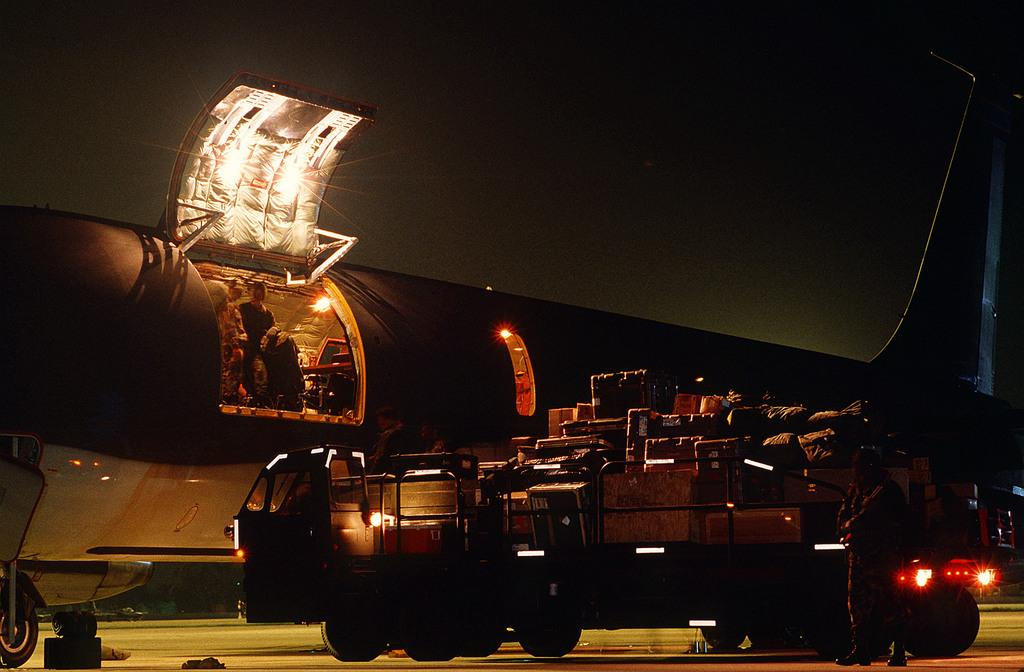What type of vehicle is on the ground in the image? There is a vehicle on the ground in the image, but the specific type is not mentioned. What other mode of transportation is present in the image? There is a plane in the image. What is the condition of the plane's emergency door? The emergency door of the plane is open. What are the people near the plane doing? People are standing near the open emergency door of the plane. Where are the cattle grazing in the image? There are no cattle present in the image. What type of dolls can be seen playing near the pear in the image? There are no dolls or pears present in the image. 